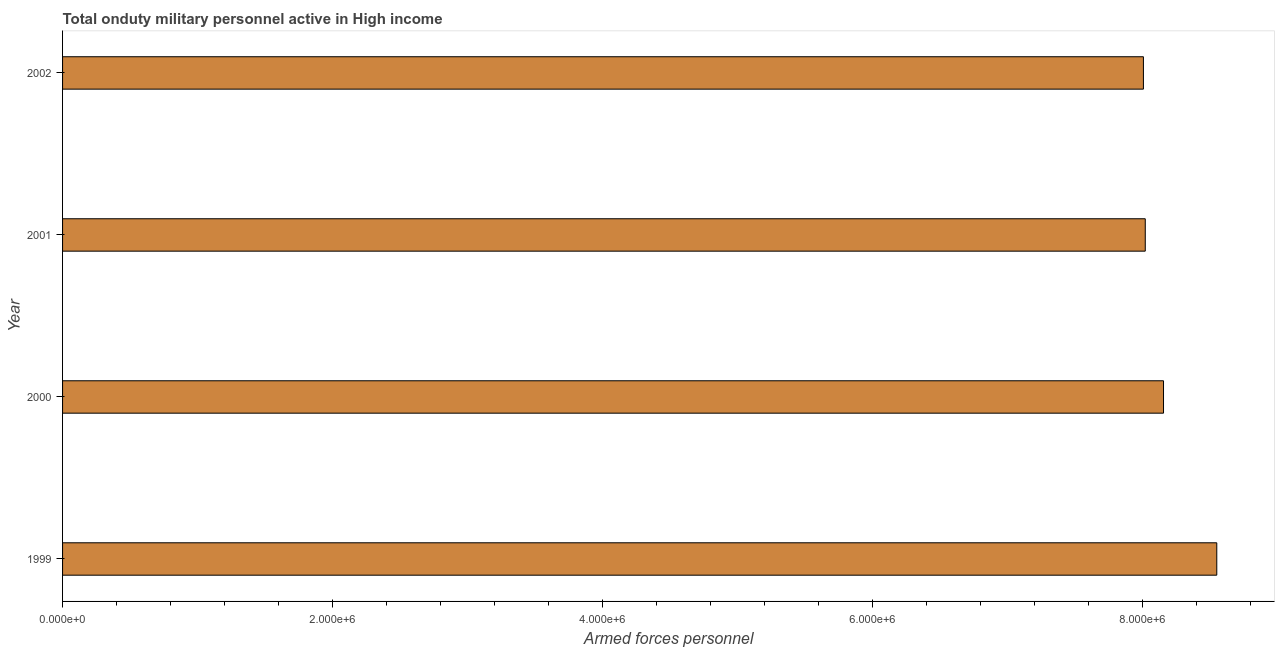Does the graph contain any zero values?
Ensure brevity in your answer.  No. What is the title of the graph?
Keep it short and to the point. Total onduty military personnel active in High income. What is the label or title of the X-axis?
Your response must be concise. Armed forces personnel. What is the label or title of the Y-axis?
Offer a terse response. Year. What is the number of armed forces personnel in 2002?
Offer a very short reply. 8.01e+06. Across all years, what is the maximum number of armed forces personnel?
Your answer should be compact. 8.55e+06. Across all years, what is the minimum number of armed forces personnel?
Provide a short and direct response. 8.01e+06. What is the sum of the number of armed forces personnel?
Your response must be concise. 3.27e+07. What is the difference between the number of armed forces personnel in 1999 and 2000?
Your response must be concise. 3.95e+05. What is the average number of armed forces personnel per year?
Offer a very short reply. 8.18e+06. What is the median number of armed forces personnel?
Keep it short and to the point. 8.09e+06. In how many years, is the number of armed forces personnel greater than 6400000 ?
Keep it short and to the point. 4. What is the ratio of the number of armed forces personnel in 1999 to that in 2000?
Your answer should be compact. 1.05. Is the number of armed forces personnel in 1999 less than that in 2000?
Give a very brief answer. No. Is the difference between the number of armed forces personnel in 1999 and 2002 greater than the difference between any two years?
Give a very brief answer. Yes. What is the difference between the highest and the second highest number of armed forces personnel?
Give a very brief answer. 3.95e+05. What is the difference between the highest and the lowest number of armed forces personnel?
Give a very brief answer. 5.43e+05. How many years are there in the graph?
Offer a very short reply. 4. What is the difference between two consecutive major ticks on the X-axis?
Your answer should be very brief. 2.00e+06. What is the Armed forces personnel of 1999?
Offer a terse response. 8.55e+06. What is the Armed forces personnel of 2000?
Keep it short and to the point. 8.16e+06. What is the Armed forces personnel in 2001?
Your answer should be compact. 8.02e+06. What is the Armed forces personnel of 2002?
Give a very brief answer. 8.01e+06. What is the difference between the Armed forces personnel in 1999 and 2000?
Offer a terse response. 3.95e+05. What is the difference between the Armed forces personnel in 1999 and 2001?
Offer a terse response. 5.30e+05. What is the difference between the Armed forces personnel in 1999 and 2002?
Offer a terse response. 5.43e+05. What is the difference between the Armed forces personnel in 2000 and 2001?
Provide a short and direct response. 1.35e+05. What is the difference between the Armed forces personnel in 2000 and 2002?
Provide a short and direct response. 1.49e+05. What is the difference between the Armed forces personnel in 2001 and 2002?
Provide a succinct answer. 1.36e+04. What is the ratio of the Armed forces personnel in 1999 to that in 2000?
Provide a short and direct response. 1.05. What is the ratio of the Armed forces personnel in 1999 to that in 2001?
Your response must be concise. 1.07. What is the ratio of the Armed forces personnel in 1999 to that in 2002?
Offer a terse response. 1.07. 